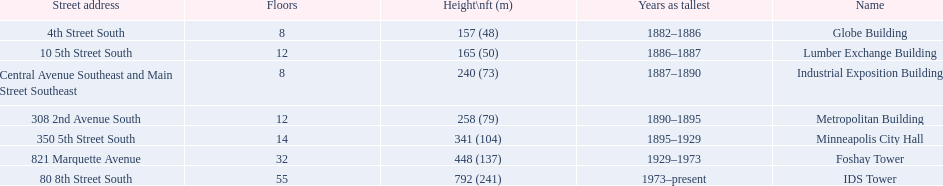What years was 240 ft considered tall? 1887–1890. What building held this record? Industrial Exposition Building. 